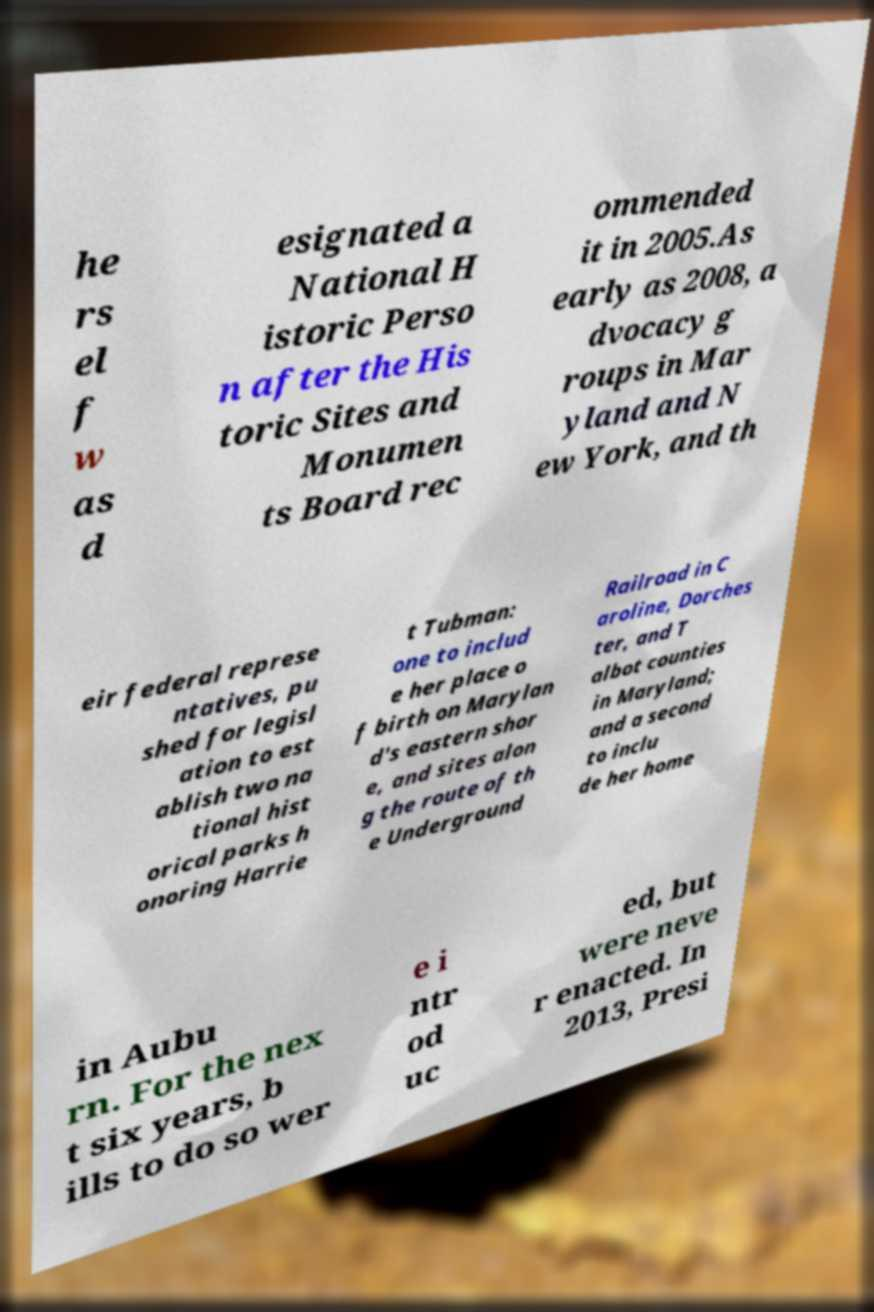There's text embedded in this image that I need extracted. Can you transcribe it verbatim? he rs el f w as d esignated a National H istoric Perso n after the His toric Sites and Monumen ts Board rec ommended it in 2005.As early as 2008, a dvocacy g roups in Mar yland and N ew York, and th eir federal represe ntatives, pu shed for legisl ation to est ablish two na tional hist orical parks h onoring Harrie t Tubman: one to includ e her place o f birth on Marylan d's eastern shor e, and sites alon g the route of th e Underground Railroad in C aroline, Dorches ter, and T albot counties in Maryland; and a second to inclu de her home in Aubu rn. For the nex t six years, b ills to do so wer e i ntr od uc ed, but were neve r enacted. In 2013, Presi 